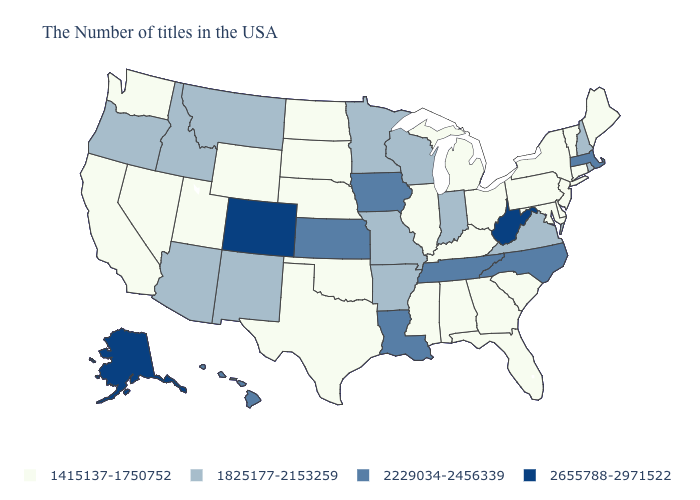Does Georgia have a lower value than Rhode Island?
Be succinct. Yes. What is the value of Arkansas?
Concise answer only. 1825177-2153259. What is the value of New Jersey?
Quick response, please. 1415137-1750752. What is the value of Kansas?
Quick response, please. 2229034-2456339. Does New Mexico have a higher value than Delaware?
Quick response, please. Yes. What is the highest value in states that border Minnesota?
Short answer required. 2229034-2456339. What is the lowest value in the South?
Answer briefly. 1415137-1750752. Name the states that have a value in the range 1825177-2153259?
Answer briefly. Rhode Island, New Hampshire, Virginia, Indiana, Wisconsin, Missouri, Arkansas, Minnesota, New Mexico, Montana, Arizona, Idaho, Oregon. Name the states that have a value in the range 2229034-2456339?
Quick response, please. Massachusetts, North Carolina, Tennessee, Louisiana, Iowa, Kansas, Hawaii. Does Massachusetts have a lower value than Colorado?
Answer briefly. Yes. What is the value of Oregon?
Be succinct. 1825177-2153259. Among the states that border Montana , does Idaho have the highest value?
Write a very short answer. Yes. Which states have the lowest value in the Northeast?
Short answer required. Maine, Vermont, Connecticut, New York, New Jersey, Pennsylvania. Which states have the highest value in the USA?
Quick response, please. West Virginia, Colorado, Alaska. Does Nevada have the lowest value in the USA?
Quick response, please. Yes. 